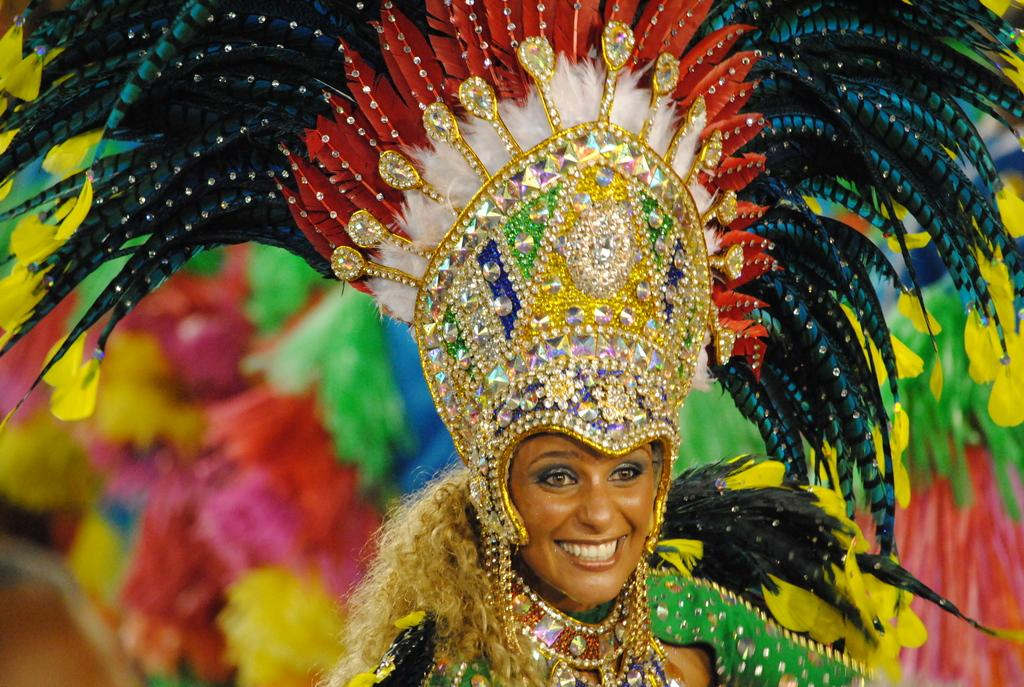Who is the main subject in the image? There is a lady in the center of the image. What is the lady wearing? The lady is wearing a costume. What expression does the lady have? The lady is smiling. What can be seen in the background of the image? There are streamers in the background of the image. What type of music is the lady singing in the image? There is no indication in the image that the lady is singing or that there is any music present. 